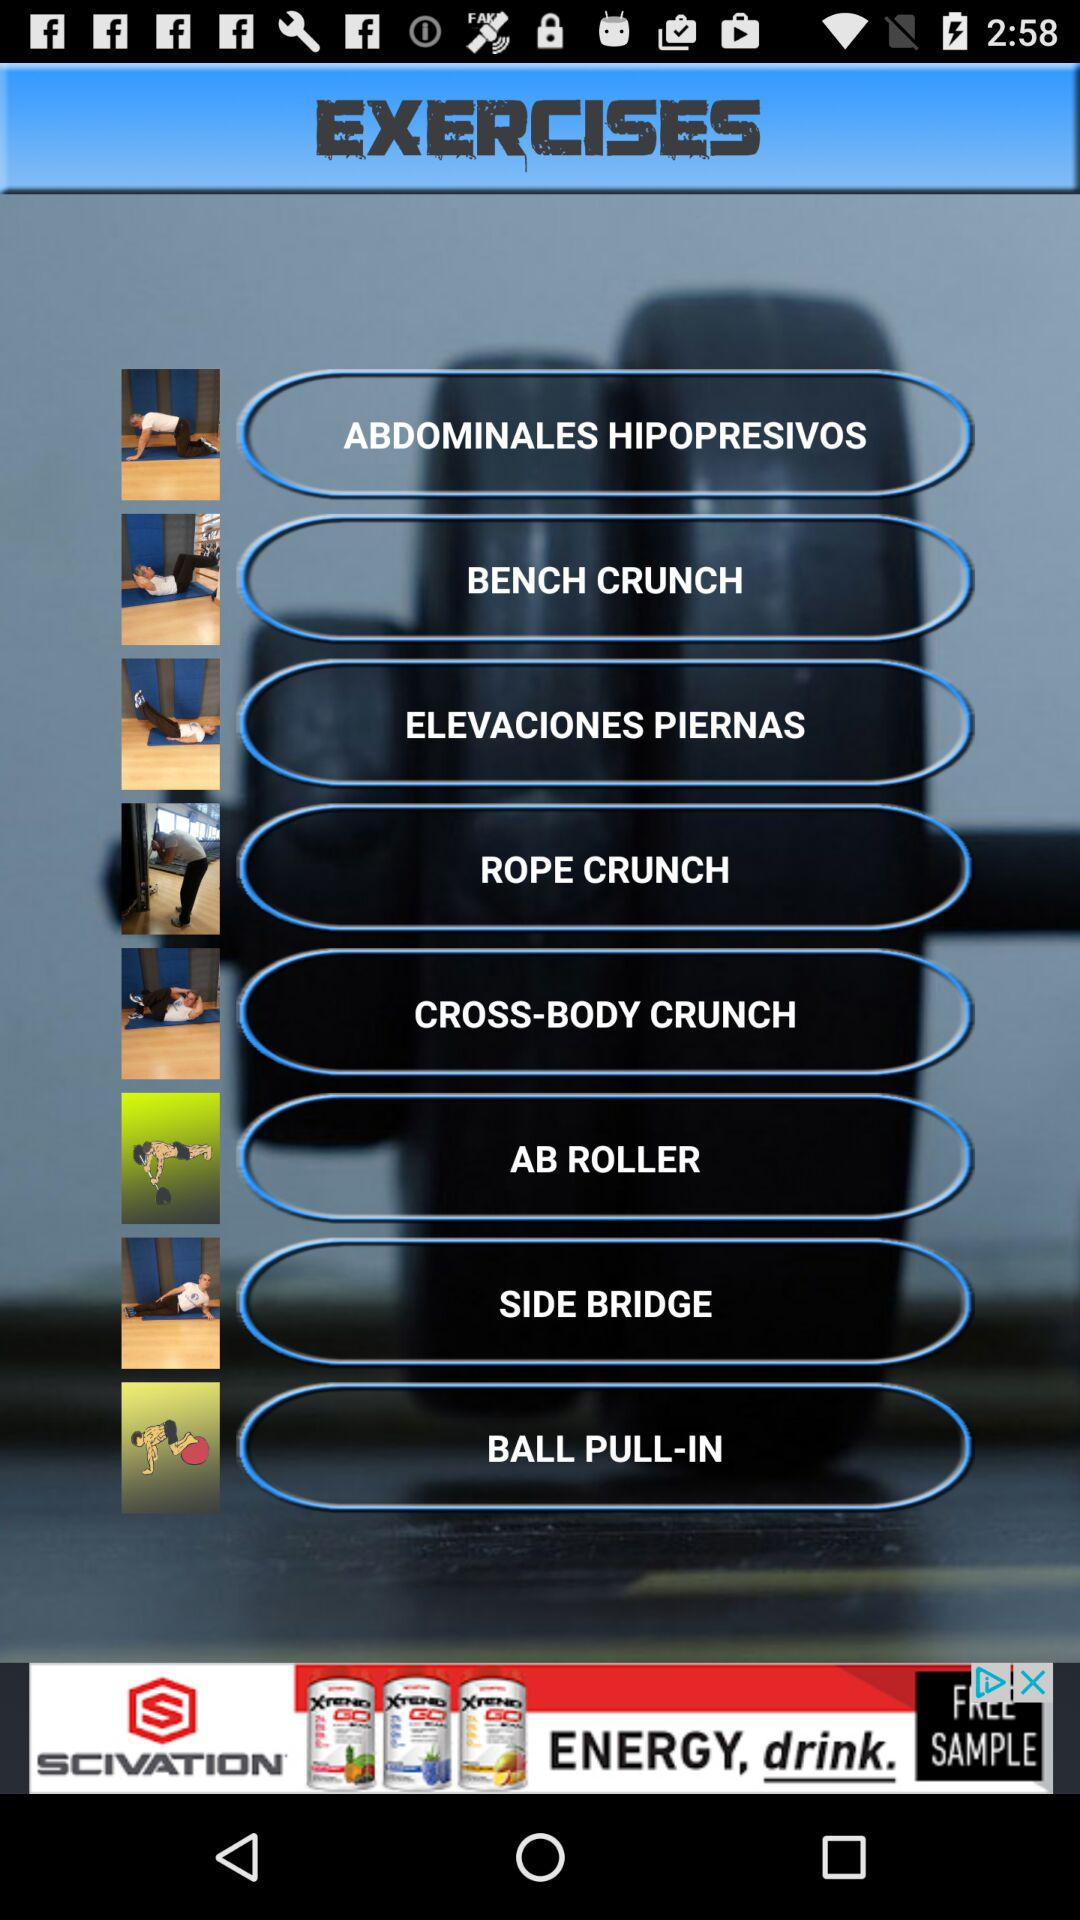What are the names of the exercises available on the screen? The exercises are abdominales hipopresivos, bench crunches, elevaciones piernas, rope crunches, cross-body crunches, ab rollers, side bridges and ball pull-ins. 